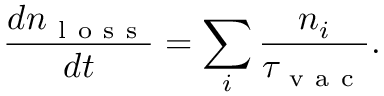<formula> <loc_0><loc_0><loc_500><loc_500>\frac { d n _ { l o s s } } { d t } = \sum _ { i } \frac { n _ { i } } { \tau _ { v a c } } .</formula> 